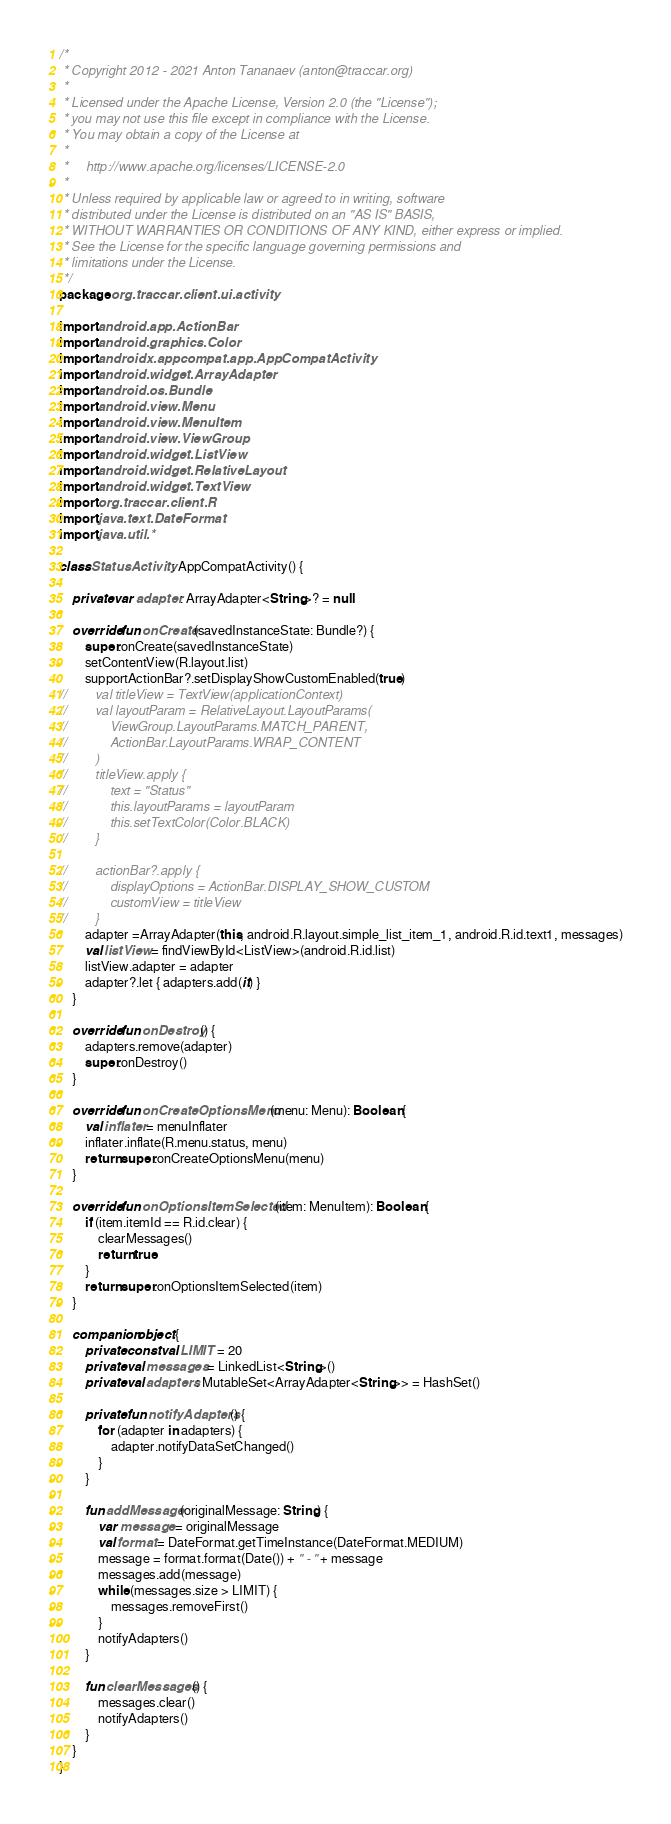Convert code to text. <code><loc_0><loc_0><loc_500><loc_500><_Kotlin_>/*
 * Copyright 2012 - 2021 Anton Tananaev (anton@traccar.org)
 *
 * Licensed under the Apache License, Version 2.0 (the "License");
 * you may not use this file except in compliance with the License.
 * You may obtain a copy of the License at
 *
 *     http://www.apache.org/licenses/LICENSE-2.0
 *
 * Unless required by applicable law or agreed to in writing, software
 * distributed under the License is distributed on an "AS IS" BASIS,
 * WITHOUT WARRANTIES OR CONDITIONS OF ANY KIND, either express or implied.
 * See the License for the specific language governing permissions and
 * limitations under the License.
 */
package org.traccar.client.ui.activity

import android.app.ActionBar
import android.graphics.Color
import androidx.appcompat.app.AppCompatActivity
import android.widget.ArrayAdapter
import android.os.Bundle
import android.view.Menu
import android.view.MenuItem
import android.view.ViewGroup
import android.widget.ListView
import android.widget.RelativeLayout
import android.widget.TextView
import org.traccar.client.R
import java.text.DateFormat
import java.util.*

class StatusActivity : AppCompatActivity() {

    private var adapter: ArrayAdapter<String>? = null

    override fun onCreate(savedInstanceState: Bundle?) {
        super.onCreate(savedInstanceState)
        setContentView(R.layout.list)
        supportActionBar?.setDisplayShowCustomEnabled(true)
//        val titleView = TextView(applicationContext)
//        val layoutParam = RelativeLayout.LayoutParams(
//            ViewGroup.LayoutParams.MATCH_PARENT,
//            ActionBar.LayoutParams.WRAP_CONTENT
//        )
//        titleView.apply {
//            text = "Status"
//            this.layoutParams = layoutParam
//            this.setTextColor(Color.BLACK)
//        }

//        actionBar?.apply {
//            displayOptions = ActionBar.DISPLAY_SHOW_CUSTOM
//            customView = titleView
//        }
        adapter =ArrayAdapter(this, android.R.layout.simple_list_item_1, android.R.id.text1, messages)
        val listView = findViewById<ListView>(android.R.id.list)
        listView.adapter = adapter
        adapter?.let { adapters.add(it) }
    }

    override fun onDestroy() {
        adapters.remove(adapter)
        super.onDestroy()
    }

    override fun onCreateOptionsMenu(menu: Menu): Boolean {
        val inflater = menuInflater
        inflater.inflate(R.menu.status, menu)
        return super.onCreateOptionsMenu(menu)
    }

    override fun onOptionsItemSelected(item: MenuItem): Boolean {
        if (item.itemId == R.id.clear) {
            clearMessages()
            return true
        }
        return super.onOptionsItemSelected(item)
    }

    companion object {
        private const val LIMIT = 20
        private val messages = LinkedList<String>()
        private val adapters: MutableSet<ArrayAdapter<String>> = HashSet()

        private fun notifyAdapters() {
            for (adapter in adapters) {
                adapter.notifyDataSetChanged()
            }
        }

        fun addMessage(originalMessage: String) {
            var message = originalMessage
            val format = DateFormat.getTimeInstance(DateFormat.MEDIUM)
            message = format.format(Date()) + " - " + message
            messages.add(message)
            while (messages.size > LIMIT) {
                messages.removeFirst()
            }
            notifyAdapters()
        }

        fun clearMessages() {
            messages.clear()
            notifyAdapters()
        }
    }
}
</code> 